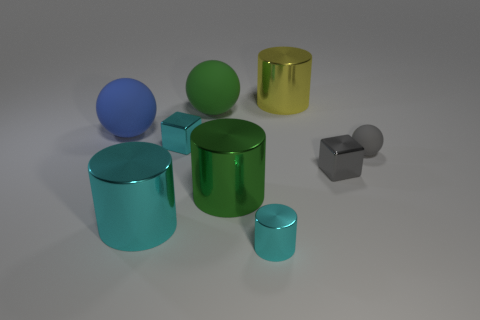There is a tiny gray metallic thing that is in front of the blue matte ball; is its shape the same as the rubber thing that is in front of the blue matte sphere?
Provide a succinct answer. No. There is a cyan block; does it have the same size as the gray rubber sphere behind the small metal cylinder?
Offer a terse response. Yes. Are there more small cyan metallic objects than blue shiny cylinders?
Your answer should be compact. Yes. Does the small cube that is to the left of the big yellow object have the same material as the ball on the right side of the small cyan metallic cylinder?
Give a very brief answer. No. What material is the yellow object?
Ensure brevity in your answer.  Metal. Is the number of gray metallic blocks in front of the small cylinder greater than the number of gray blocks?
Provide a short and direct response. No. What number of green metallic objects are in front of the cylinder on the left side of the cyan thing that is behind the big cyan thing?
Provide a short and direct response. 0. What material is the tiny thing that is behind the tiny gray metallic cube and to the left of the yellow shiny cylinder?
Provide a short and direct response. Metal. The small cylinder is what color?
Make the answer very short. Cyan. Is the number of cyan objects in front of the gray ball greater than the number of large green metal cylinders that are in front of the green shiny thing?
Keep it short and to the point. Yes. 